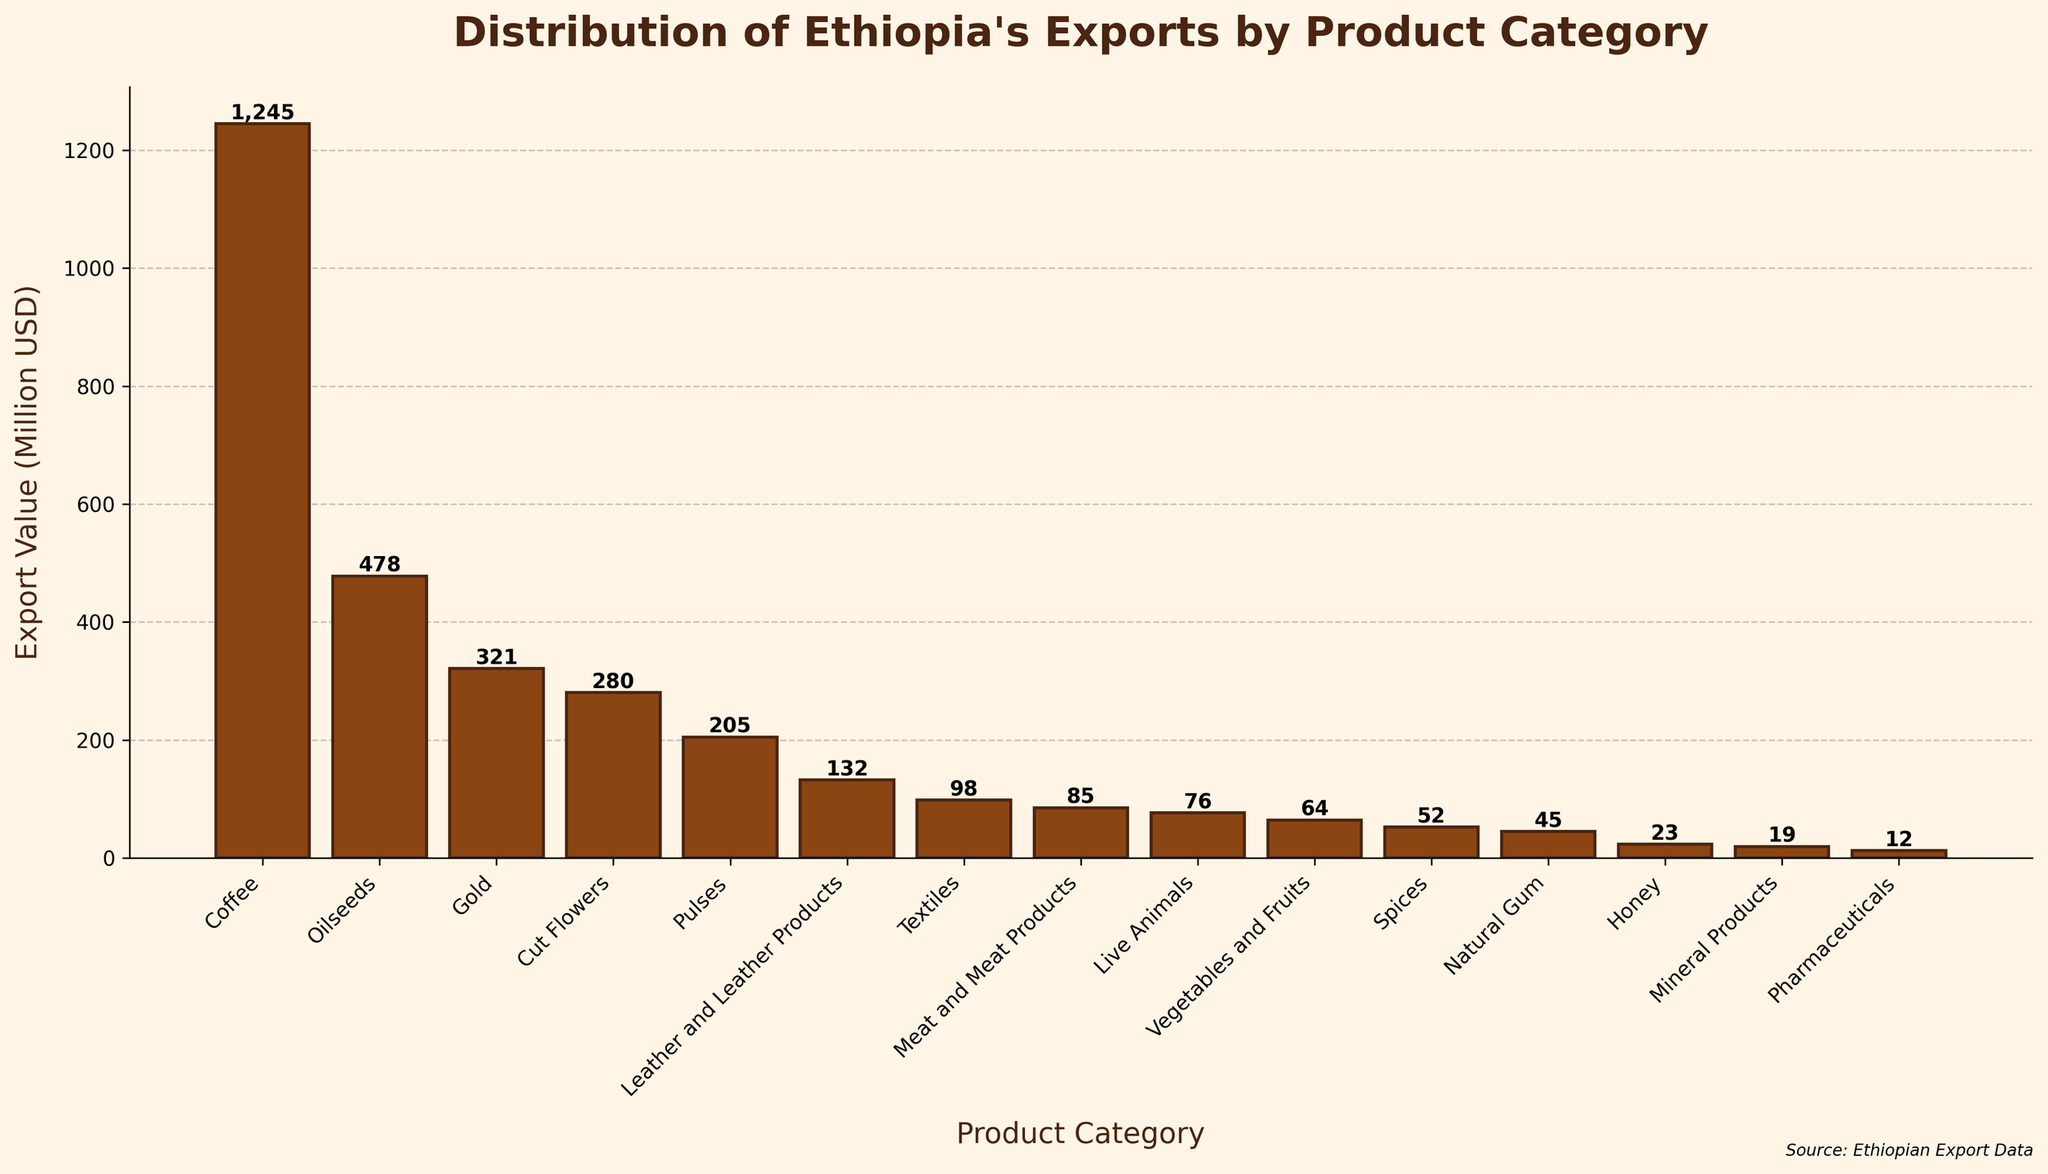What is the highest export value product category? Look at the top bar in the bar chart, which represents the product category with the highest export value. In this case, it is "Coffee" with 1245 million USD.
Answer: Coffee Which product categories have an export value between 50 and 100 million USD? Identify the bars that lie within the range of 50 to 100 million USD by examining their heights and the value labels on top of each bar. These are "Textiles" (98), "Meat and Meat Products" (85), "Live Animals" (76), "Vegetables and Fruits" (64), and "Spices" (52).
Answer: Textiles, Meat and Meat Products, Live Animals, Vegetables and Fruits, Spices What is the total export value of the top three product categories? Sum the export values of the top three product categories: Coffee (1245), Oilseeds (478), and Gold (321). The total is 1245 + 478 + 321 = 2044 million USD.
Answer: 2044 million USD How does the export value of Leather and Leather Products compare to that of Meat and Meat Products? Look at the bars corresponding to "Leather and Leather Products" and "Meat and Meat Products" and compare their heights. Leather and Leather Products have an export value of 132 million USD, while Meat and Meat Products have 85 million USD. Leather and Leather Products have a higher export value.
Answer: Leather and Leather Products have a higher export value than Meat and Meat Products Which product category has the lowest export value? Identify the shortest bar in the bar chart, which represents the product category with the lowest export value. In this case, it is "Pharmaceuticals" with 12 million USD.
Answer: Pharmaceuticals What is the difference in export value between Oilseeds and Cut Flowers? Subtract the export value of Cut Flowers from that of Oilseeds: 478 (Oilseeds) - 280 (Cut Flowers) = 198 million USD.
Answer: 198 million USD How many product categories have an export value greater than 100 million USD? Count the number of bars with export values above 100 million USD by looking at the heights and value labels. These are Coffee, Oilseeds, Gold, and Cut Flowers, totaling 4 categories.
Answer: 4 What is the average export value of all product categories? Sum all the export values and divide by the number of categories. (1245 + 478 + 321 + 280 + 132 + 205 + 98 + 85 + 76 + 64 + 52 + 45 + 23 + 19 + 12) / 15 = 3135 / 15 = 209 million USD.
Answer: 209 million USD How does the export value of Natural Gum compare visually to that of Honey? Observe the bars representing Natural Gum and Honey. Both bars are relatively short, but the bar for Honey is shorter than that for Natural Gum.
Answer: Natural Gum has a higher export value than Honey 